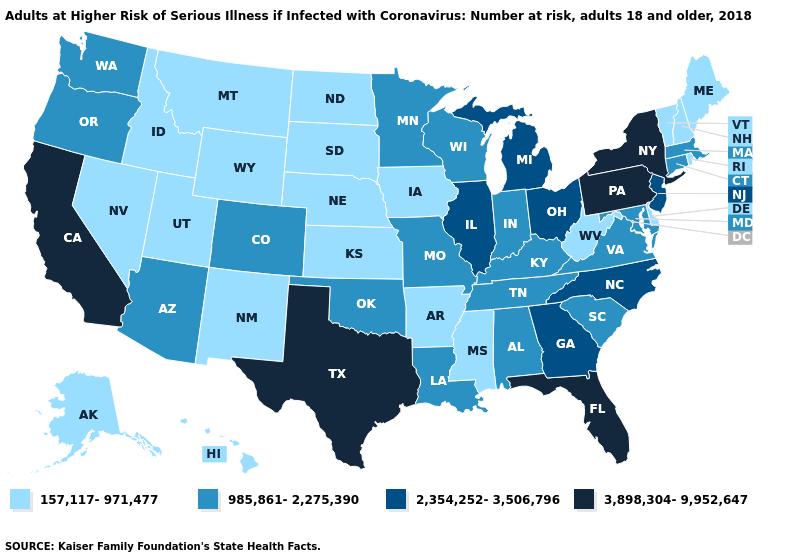What is the value of Virginia?
Answer briefly. 985,861-2,275,390. What is the highest value in the West ?
Answer briefly. 3,898,304-9,952,647. What is the lowest value in the USA?
Be succinct. 157,117-971,477. Does Vermont have the lowest value in the Northeast?
Concise answer only. Yes. What is the value of Florida?
Answer briefly. 3,898,304-9,952,647. Does Pennsylvania have the same value as California?
Short answer required. Yes. Which states have the highest value in the USA?
Quick response, please. California, Florida, New York, Pennsylvania, Texas. What is the lowest value in the USA?
Be succinct. 157,117-971,477. What is the highest value in the USA?
Answer briefly. 3,898,304-9,952,647. What is the value of North Dakota?
Give a very brief answer. 157,117-971,477. What is the value of Iowa?
Be succinct. 157,117-971,477. Which states hav the highest value in the West?
Short answer required. California. What is the value of South Dakota?
Quick response, please. 157,117-971,477. Among the states that border North Dakota , does Montana have the highest value?
Quick response, please. No. Does the map have missing data?
Quick response, please. No. 